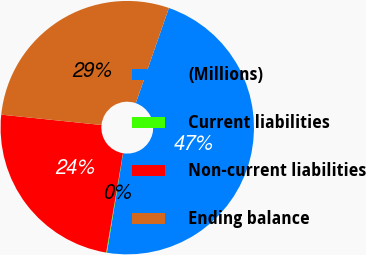<chart> <loc_0><loc_0><loc_500><loc_500><pie_chart><fcel>(Millions)<fcel>Current liabilities<fcel>Non-current liabilities<fcel>Ending balance<nl><fcel>47.24%<fcel>0.09%<fcel>23.97%<fcel>28.69%<nl></chart> 